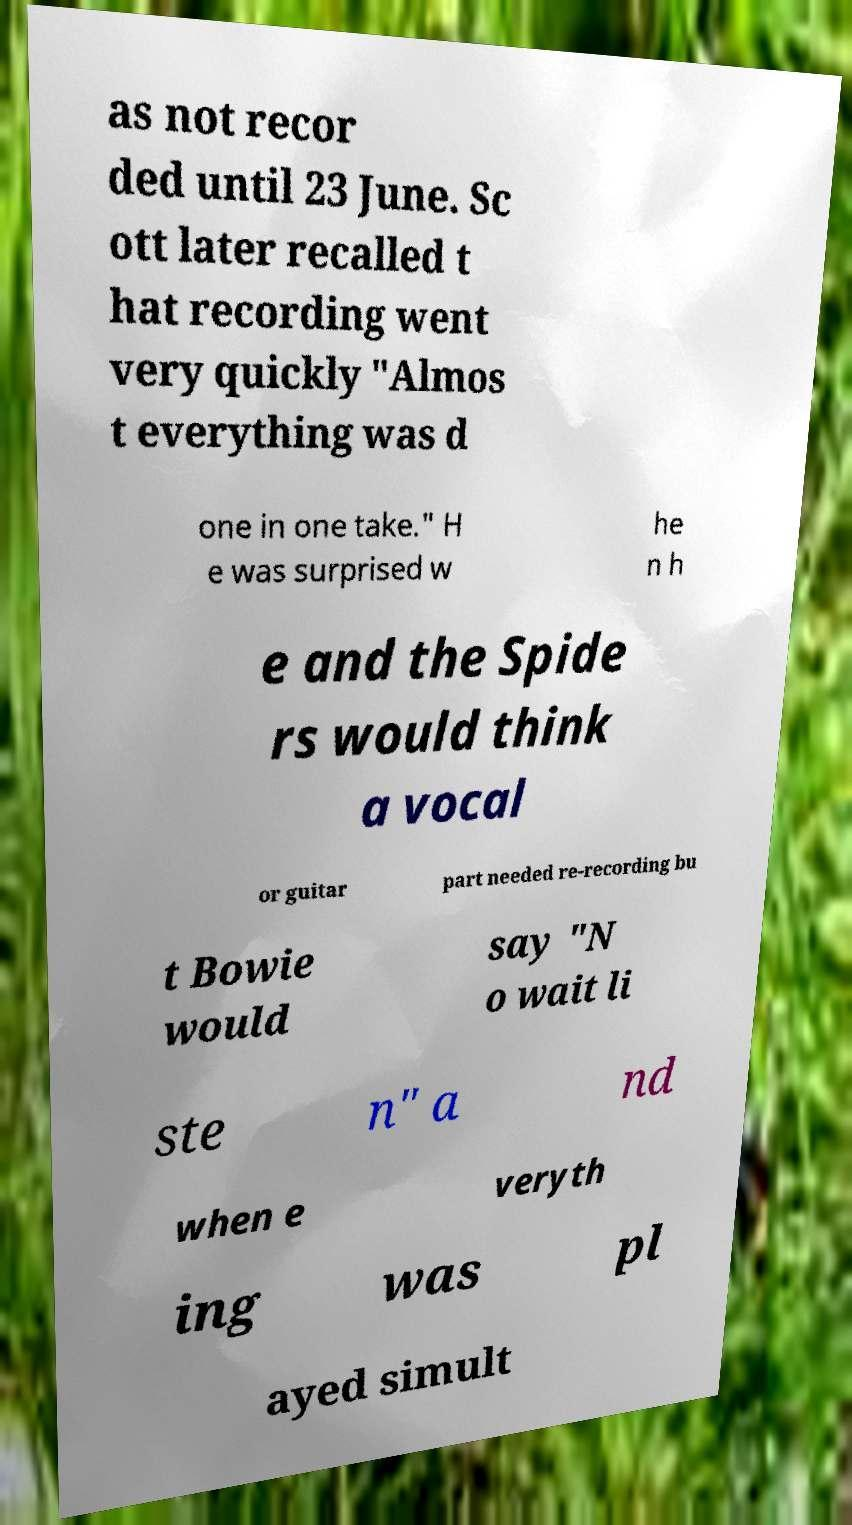Can you read and provide the text displayed in the image?This photo seems to have some interesting text. Can you extract and type it out for me? as not recor ded until 23 June. Sc ott later recalled t hat recording went very quickly "Almos t everything was d one in one take." H e was surprised w he n h e and the Spide rs would think a vocal or guitar part needed re-recording bu t Bowie would say "N o wait li ste n" a nd when e veryth ing was pl ayed simult 